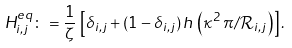<formula> <loc_0><loc_0><loc_500><loc_500>H ^ { e q } _ { i , j } \colon = \frac { 1 } { \zeta } \, \left [ \delta _ { i , j } + ( 1 - \delta _ { i , j } ) \, h \, \left ( \kappa ^ { 2 } \, \pi / \mathcal { R } _ { i , j } \right ) \right ] .</formula> 